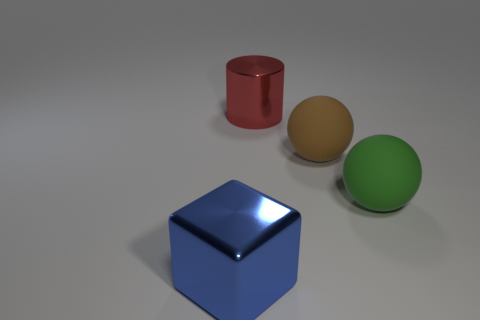Add 2 tiny cyan cylinders. How many objects exist? 6 Subtract all cylinders. How many objects are left? 3 Add 4 large green objects. How many large green objects are left? 5 Add 4 rubber things. How many rubber things exist? 6 Subtract 0 cyan cubes. How many objects are left? 4 Subtract all big matte cylinders. Subtract all metallic things. How many objects are left? 2 